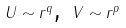<formula> <loc_0><loc_0><loc_500><loc_500>U \sim r ^ { q } \text {, } V \sim r ^ { p }</formula> 